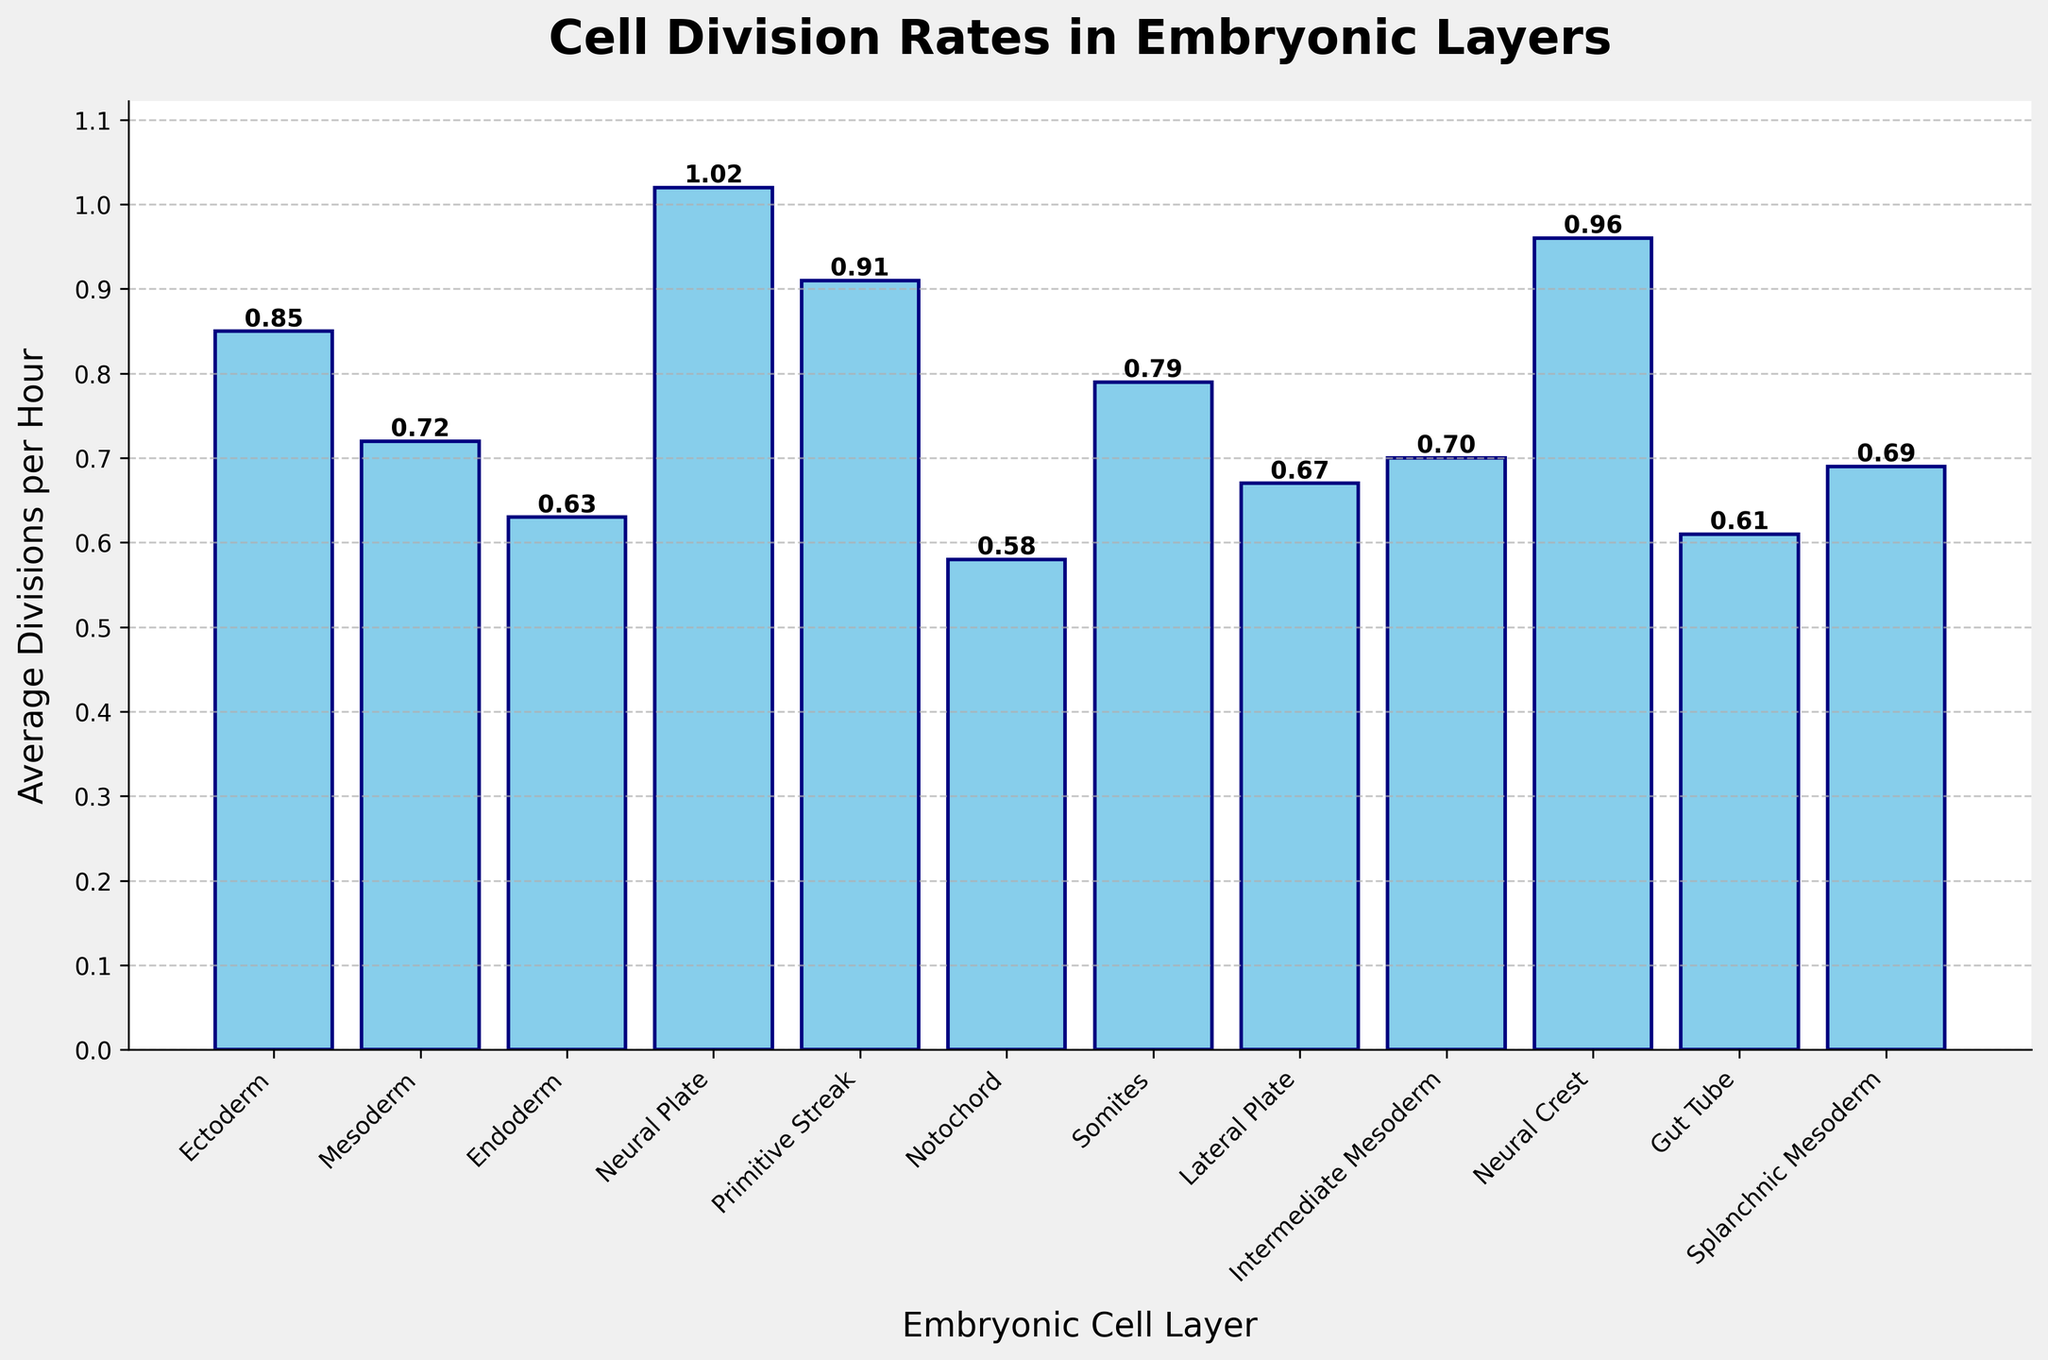Which embryonic cell layer has the highest average cell division rate? By observing the heights of the bars, the Neural Plate has the tallest bar, indicating it has the highest average cell division rate.
Answer: Neural Plate Which embryonic cell layer has the lowest average cell division rate? By examining the shortest bar, the Notochord has the shortest bar, thus the lowest average cell division rate.
Answer: Notochord What is the difference in average cell division rates between the Neural Crest and the Endoderm? The average division rate for Neural Crest is 0.96 and for Endoderm is 0.63. The difference is 0.96 - 0.63 = 0.33.
Answer: 0.33 How many cell layers have an average division rate greater than 0.85? From the figure, the Neural Plate (1.02), Primitive Streak (0.91), and Neural Crest (0.96) all have rates greater than 0.85. There are 3 layers in total.
Answer: 3 Which layer has a higher cell division rate: the Lateral Plate or the Splanchnic Mesoderm? By comparing the heights of the bars, the Lateral Plate appears slightly taller with a division rate of 0.67 compared to the Splanchnic Mesoderm's 0.69. So, the Splanchnic Mesoderm has a higher rate.
Answer: Splanchnic Mesoderm What is the average cell division rate across all the layers? To find the average, add all the division rates and divide by the number of layers: (0.85 + 0.72 + 0.63 + 1.02 + 0.91 + 0.58 + 0.79 + 0.67 + 0.70 + 0.96 + 0.61 + 0.69) / 12 = 0.758333....
Answer: 0.76 Is there a visible trend in the average cell division rates from the Ectoderm to Gut Tube? Visually, there's no clear increasing or decreasing trend; the rates fluctuate across the layers. One must specifically analyze each bar to determine.
Answer: No clear trend What is the combined average cell division rate of the Mesoderm, Notochord, and Somites? Sum the rates for Mesoderm (0.72), Notochord (0.58), and Somites (0.79), then divide by 3: (0.72 + 0.58 + 0.79) / 3 = 0.6967.
Answer: 0.70 Among the given cell layers, which ones are represented using the shortest three bars? By visually identifying, the shortest three bars correspond to Notochord (0.58), Gut Tube (0.61), and Endoderm (0.63) layers.
Answer: Notochord, Gut Tube, Endoderm What is the range of the average cell division rates depicted in the chart? The range is determined by subtracting the lowest rate from the highest rate: 1.02 (Neural Plate) - 0.58 (Notochord) = 0.44.
Answer: 0.44 